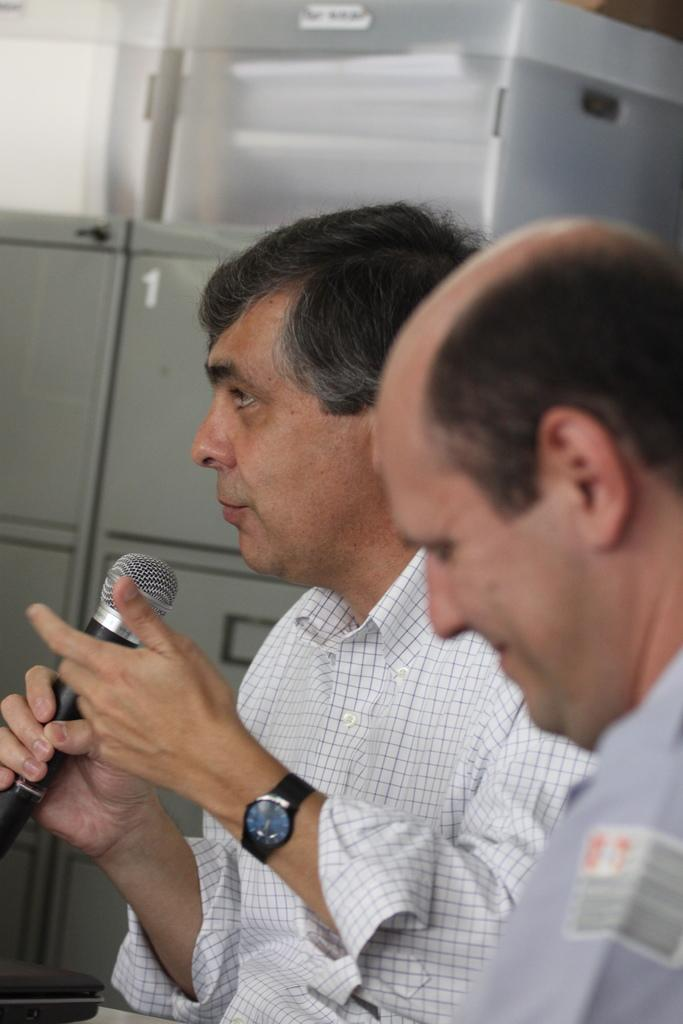How many people are in the image? There are two persons in the image. Can you describe one of the persons in the image? One of the persons is a man. What is the man holding in his hands? The man is holding a mic in his hands. What can be seen in the background of the image? There are plastic boxes in the background of the image. What is inside the plastic boxes? The plastic boxes contain pages. What are the plastic boxes placed on? The plastic boxes are on metal locker boxes. How many houses can be seen in the image? There are no houses visible in the image. What type of polish is being applied to the sheep in the image? There are no sheep or polish present in the image. 